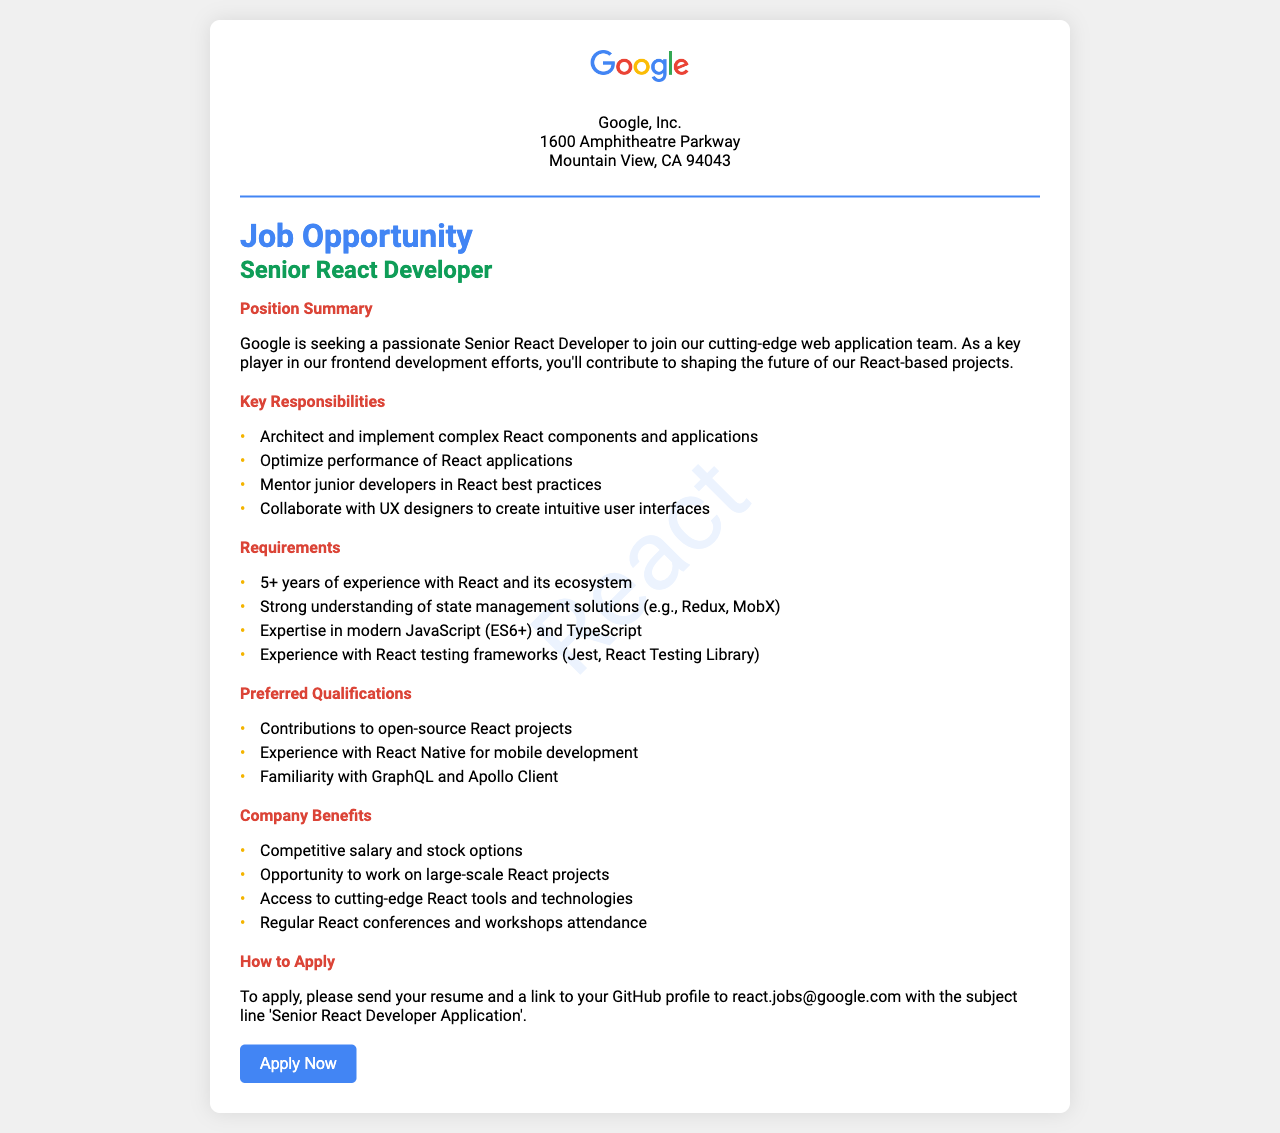What is the job title? The job title mentioned in the document is clearly stated under "job title."
Answer: Senior React Developer What is the required experience for the position? The document specifies a minimum experience requirement listed under "Requirements."
Answer: 5+ years What is the email address to apply? The application email is found in the "How to Apply" section.
Answer: react.jobs@google.com What is one of the key responsibilities? One of the key responsibilities is listed in the "Key Responsibilities" section.
Answer: Mentor junior developers in React best practices Which programming language is specifically mentioned as part of the requirements? The requirements include a specific programming language noted in the "Requirements" section.
Answer: TypeScript What is one of the preferred qualifications? A preferred qualification is mentioned in the "Preferred Qualifications" section of the document.
Answer: Contributions to open-source React projects What benefit relates to professional development? A benefit regarding professional growth can be found in the "Company Benefits" section.
Answer: Regular React conferences and workshops attendance What company is offering this job? The company name is stated right at the beginning of the document.
Answer: Google, Inc 